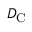Convert formula to latex. <formula><loc_0><loc_0><loc_500><loc_500>D _ { C }</formula> 